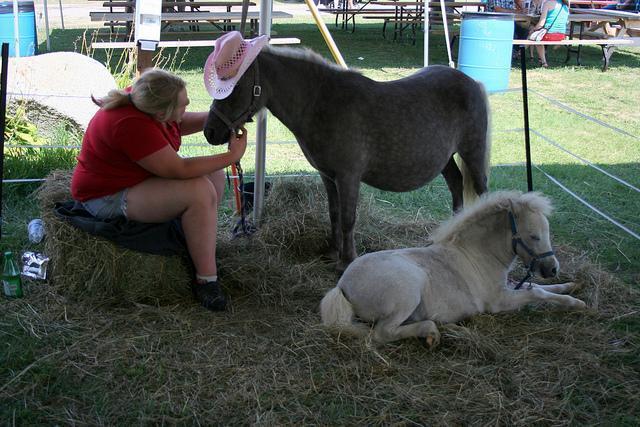The woman is putting what piece of her safety riding gear on the pony?
Choose the correct response, then elucidate: 'Answer: answer
Rationale: rationale.'
Options: Harness, glasses, hat, whip. Answer: harness.
Rationale: The woman is putting a harness on the mouth of the horse. 